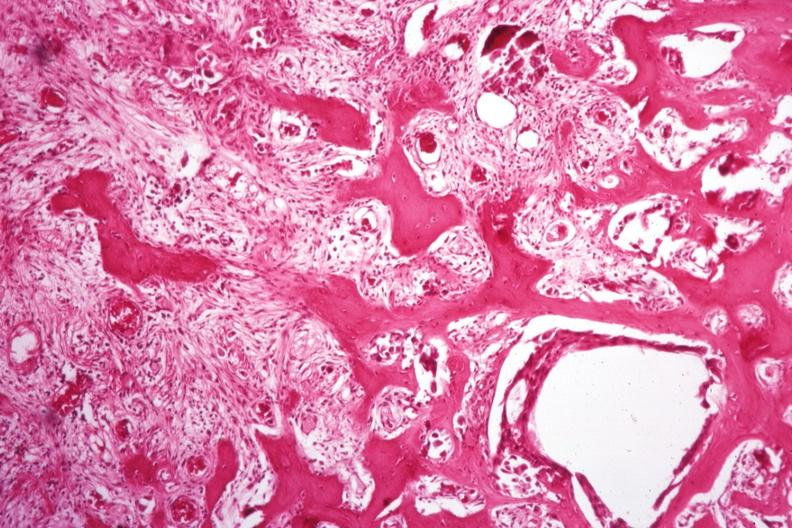s joints present?
Answer the question using a single word or phrase. Yes 